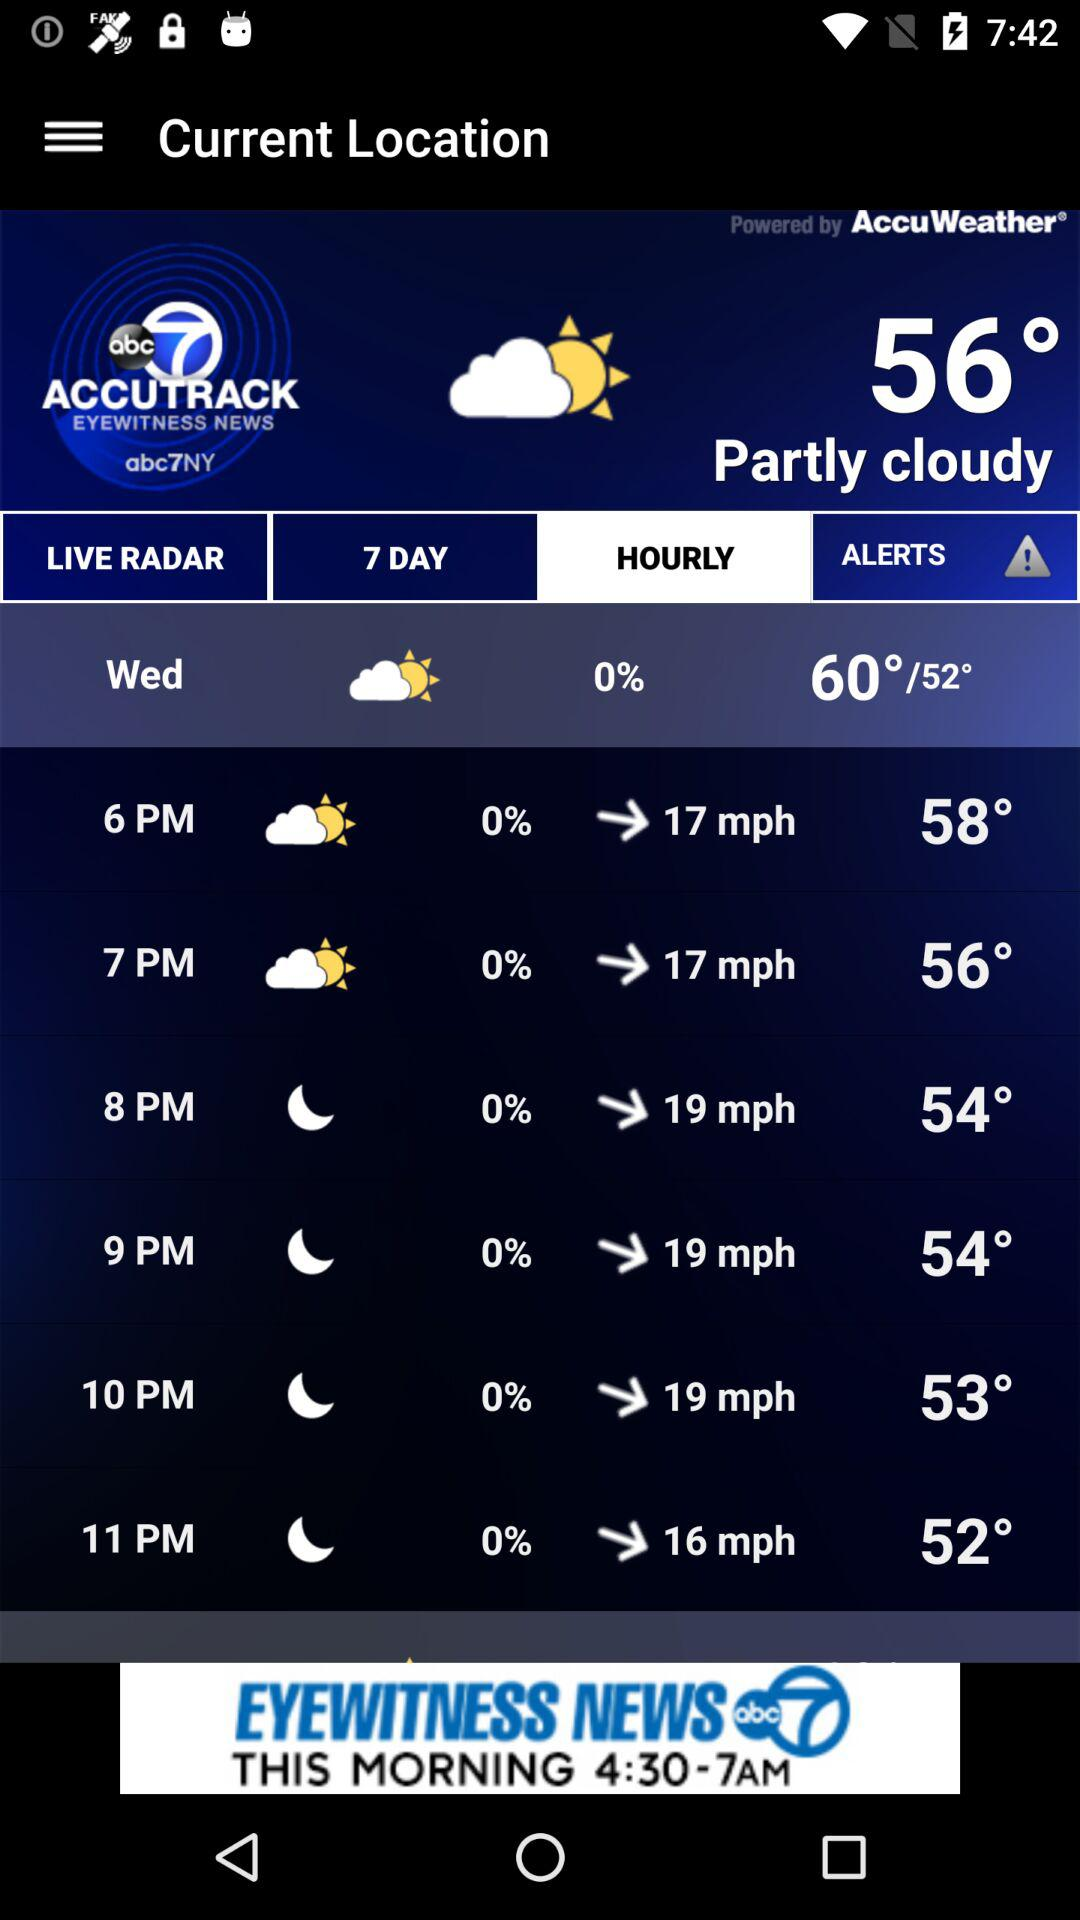How many hours are there between 6pm and 11pm?
Answer the question using a single word or phrase. 5 